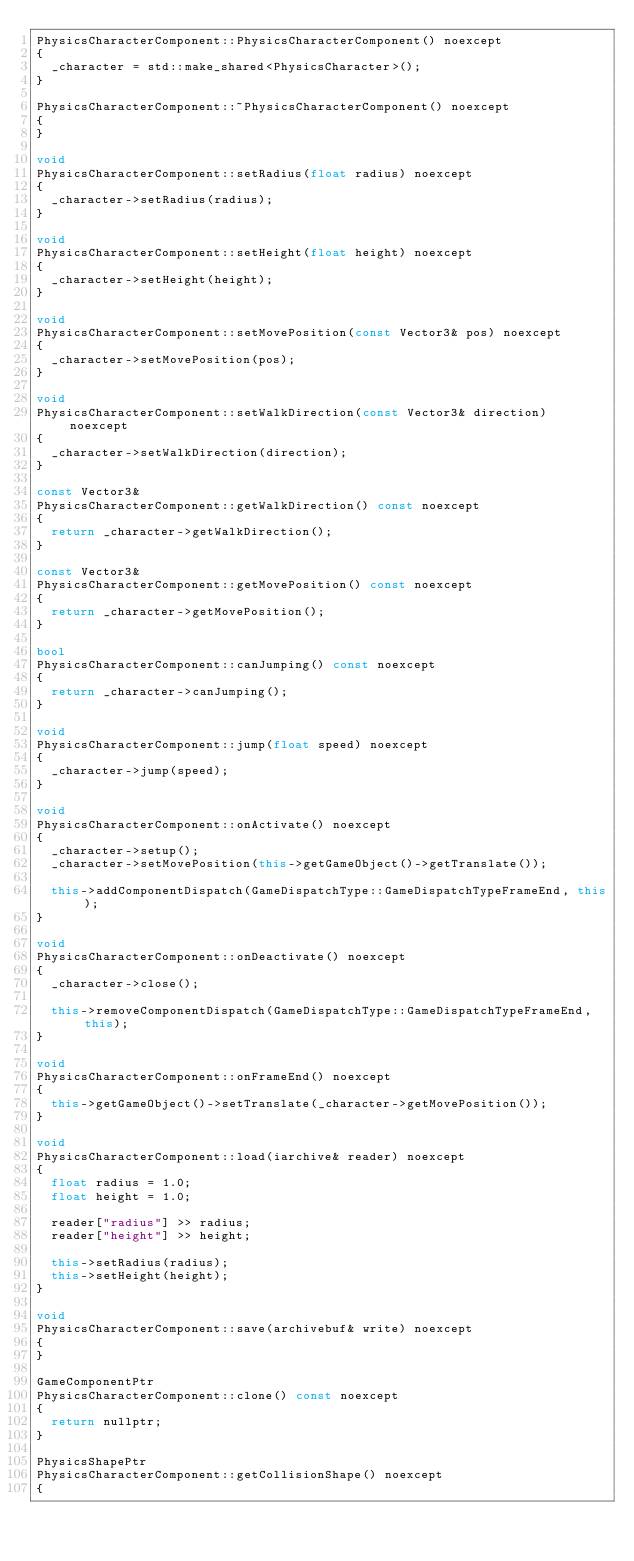Convert code to text. <code><loc_0><loc_0><loc_500><loc_500><_C++_>PhysicsCharacterComponent::PhysicsCharacterComponent() noexcept
{
	_character = std::make_shared<PhysicsCharacter>();
}

PhysicsCharacterComponent::~PhysicsCharacterComponent() noexcept
{
}

void
PhysicsCharacterComponent::setRadius(float radius) noexcept
{
	_character->setRadius(radius);
}

void
PhysicsCharacterComponent::setHeight(float height) noexcept
{
	_character->setHeight(height);
}

void
PhysicsCharacterComponent::setMovePosition(const Vector3& pos) noexcept
{
	_character->setMovePosition(pos);
}

void
PhysicsCharacterComponent::setWalkDirection(const Vector3& direction) noexcept
{
	_character->setWalkDirection(direction);
}

const Vector3&
PhysicsCharacterComponent::getWalkDirection() const noexcept
{
	return _character->getWalkDirection();
}

const Vector3&
PhysicsCharacterComponent::getMovePosition() const noexcept
{
	return _character->getMovePosition();
}

bool
PhysicsCharacterComponent::canJumping() const noexcept
{
	return _character->canJumping();
}

void
PhysicsCharacterComponent::jump(float speed) noexcept
{
	_character->jump(speed);
}

void
PhysicsCharacterComponent::onActivate() noexcept
{
	_character->setup();
	_character->setMovePosition(this->getGameObject()->getTranslate());

	this->addComponentDispatch(GameDispatchType::GameDispatchTypeFrameEnd, this);
}

void
PhysicsCharacterComponent::onDeactivate() noexcept
{
	_character->close();

	this->removeComponentDispatch(GameDispatchType::GameDispatchTypeFrameEnd, this);
}

void
PhysicsCharacterComponent::onFrameEnd() noexcept
{
	this->getGameObject()->setTranslate(_character->getMovePosition());
}

void
PhysicsCharacterComponent::load(iarchive& reader) noexcept
{
	float radius = 1.0;
	float height = 1.0;

	reader["radius"] >> radius;
	reader["height"] >> height;

	this->setRadius(radius);
	this->setHeight(height);
}

void
PhysicsCharacterComponent::save(archivebuf& write) noexcept
{
}

GameComponentPtr
PhysicsCharacterComponent::clone() const noexcept
{
	return nullptr;
}

PhysicsShapePtr
PhysicsCharacterComponent::getCollisionShape() noexcept
{</code> 